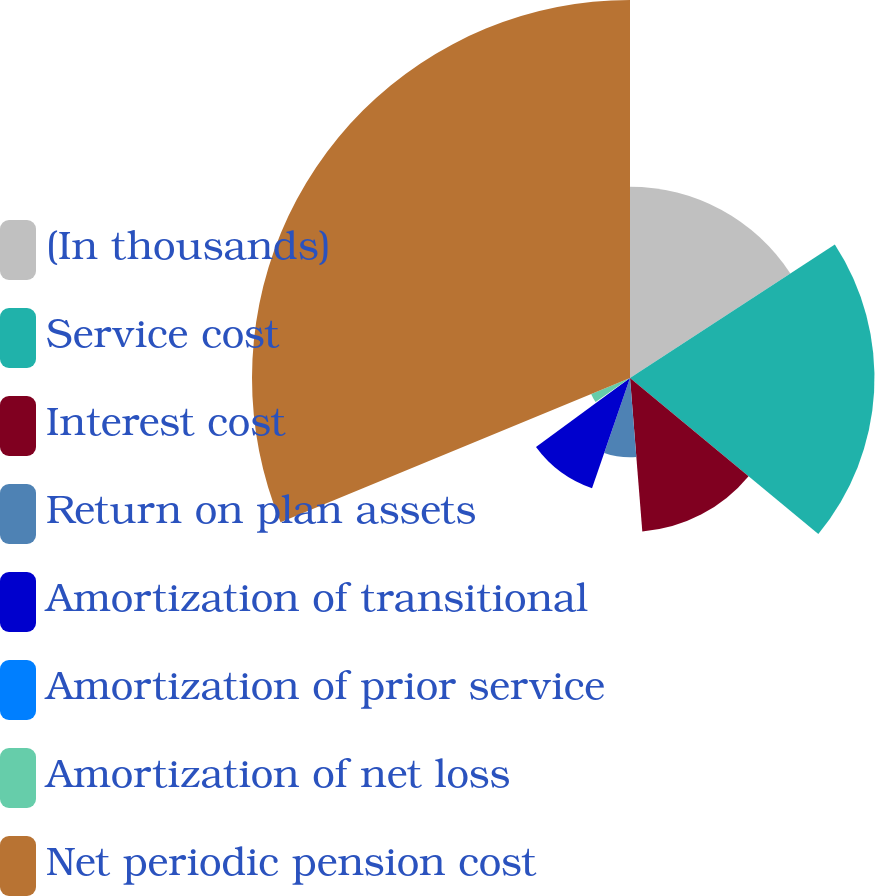<chart> <loc_0><loc_0><loc_500><loc_500><pie_chart><fcel>(In thousands)<fcel>Service cost<fcel>Interest cost<fcel>Return on plan assets<fcel>Amortization of transitional<fcel>Amortization of prior service<fcel>Amortization of net loss<fcel>Net periodic pension cost<nl><fcel>15.81%<fcel>20.2%<fcel>12.72%<fcel>6.55%<fcel>9.64%<fcel>0.39%<fcel>3.47%<fcel>31.23%<nl></chart> 